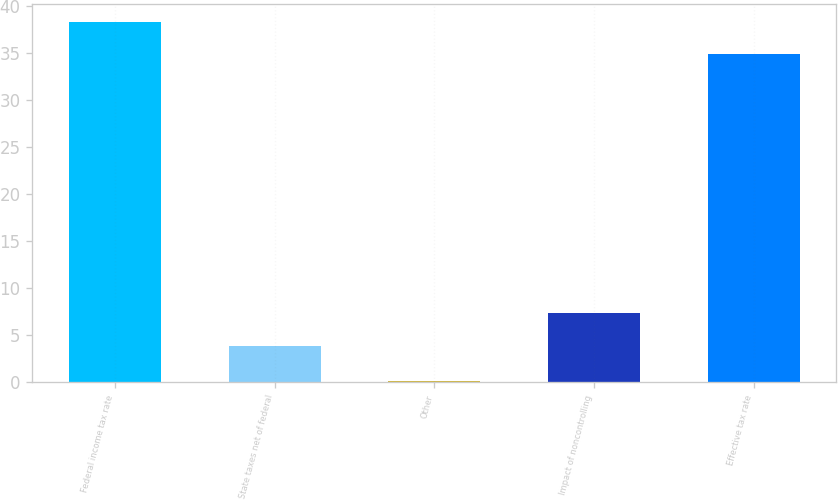Convert chart to OTSL. <chart><loc_0><loc_0><loc_500><loc_500><bar_chart><fcel>Federal income tax rate<fcel>State taxes net of federal<fcel>Other<fcel>Impact of noncontrolling<fcel>Effective tax rate<nl><fcel>38.39<fcel>3.9<fcel>0.1<fcel>7.39<fcel>34.9<nl></chart> 